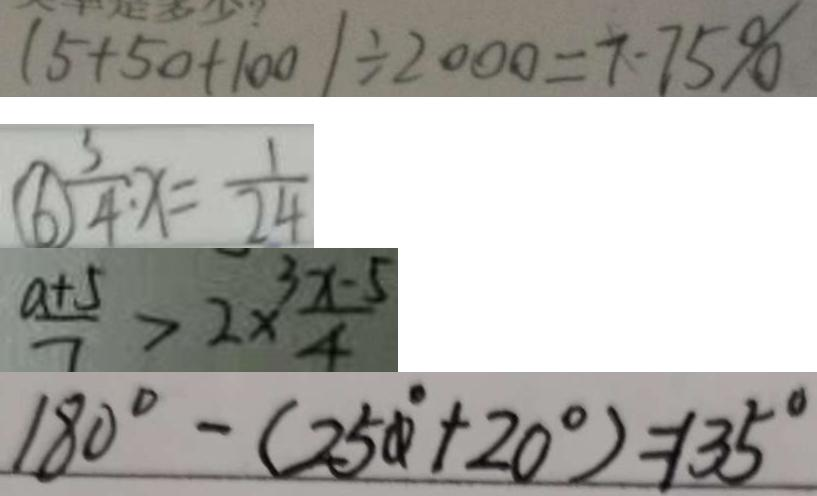Convert formula to latex. <formula><loc_0><loc_0><loc_500><loc_500>( 5 + 5 0 + 1 0 0 ) \div 2 0 0 0 = 7 \cdot 7 5 \% 
 \textcircled { 6 } \frac { 3 } { 4 } : x = \frac { 1 } { 2 4 } 
 \frac { a + 5 } { 7 } > 2 \times \frac { 3 x - 5 } { 4 } 
 1 8 0 ^ { \circ } - ( 2 5 0 ^ { \circ } + 2 0 ^ { \circ } ) = 1 3 5 ^ { \circ }</formula> 